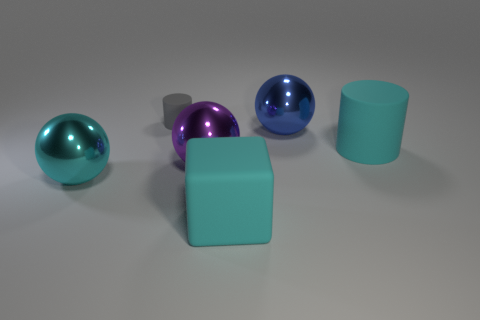Subtract all cyan metallic balls. How many balls are left? 2 Subtract all brown spheres. Subtract all gray cubes. How many spheres are left? 3 Add 4 large cyan balls. How many objects exist? 10 Subtract all cylinders. How many objects are left? 4 Add 1 big cyan matte spheres. How many big cyan matte spheres exist? 1 Subtract 1 gray cylinders. How many objects are left? 5 Subtract all cyan metal balls. Subtract all brown rubber spheres. How many objects are left? 5 Add 4 small objects. How many small objects are left? 5 